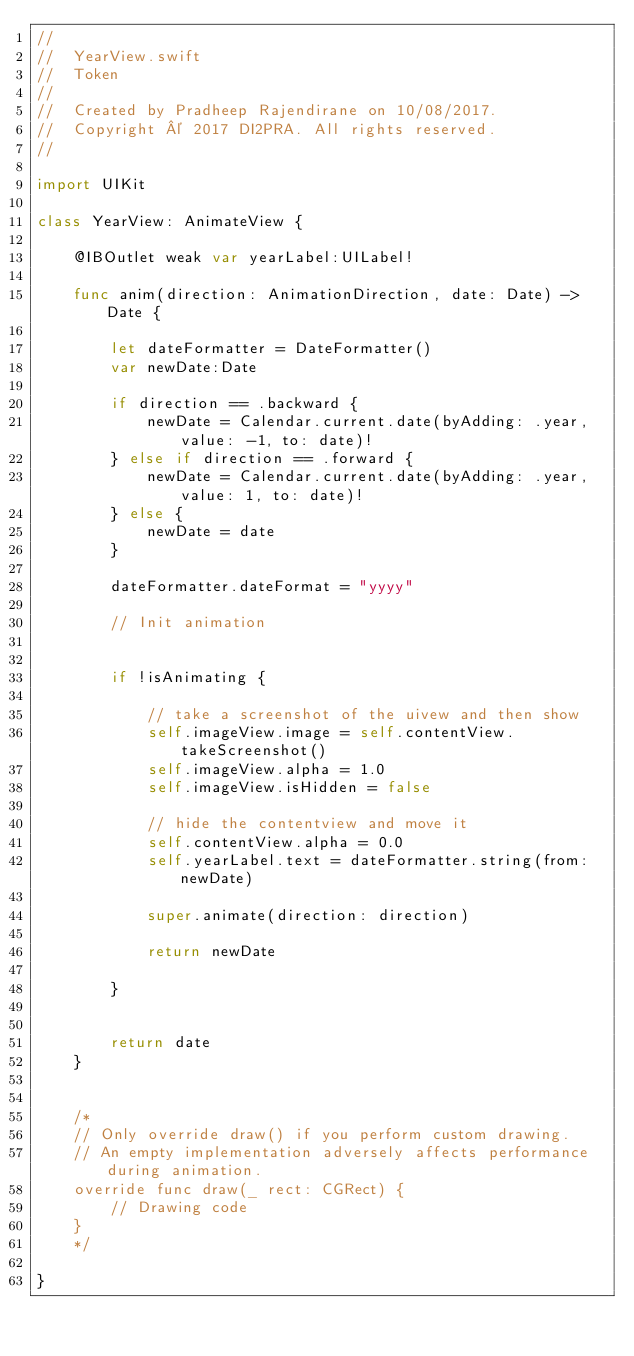Convert code to text. <code><loc_0><loc_0><loc_500><loc_500><_Swift_>//
//  YearView.swift
//  Token
//
//  Created by Pradheep Rajendirane on 10/08/2017.
//  Copyright © 2017 DI2PRA. All rights reserved.
//

import UIKit

class YearView: AnimateView {
    
    @IBOutlet weak var yearLabel:UILabel!
    
    func anim(direction: AnimationDirection, date: Date) -> Date {
        
        let dateFormatter = DateFormatter()
        var newDate:Date
        
        if direction == .backward {
            newDate = Calendar.current.date(byAdding: .year, value: -1, to: date)!
        } else if direction == .forward {
            newDate = Calendar.current.date(byAdding: .year, value: 1, to: date)!
        } else {
            newDate = date
        }
        
        dateFormatter.dateFormat = "yyyy"
        
        // Init animation
        
        
        if !isAnimating {
            
            // take a screenshot of the uivew and then show
            self.imageView.image = self.contentView.takeScreenshot()
            self.imageView.alpha = 1.0
            self.imageView.isHidden = false
            
            // hide the contentview and move it
            self.contentView.alpha = 0.0
            self.yearLabel.text = dateFormatter.string(from: newDate)
            
            super.animate(direction: direction)
            
            return newDate
            
        }
        
        
        return date
    }


    /*
    // Only override draw() if you perform custom drawing.
    // An empty implementation adversely affects performance during animation.
    override func draw(_ rect: CGRect) {
        // Drawing code
    }
    */

}
</code> 